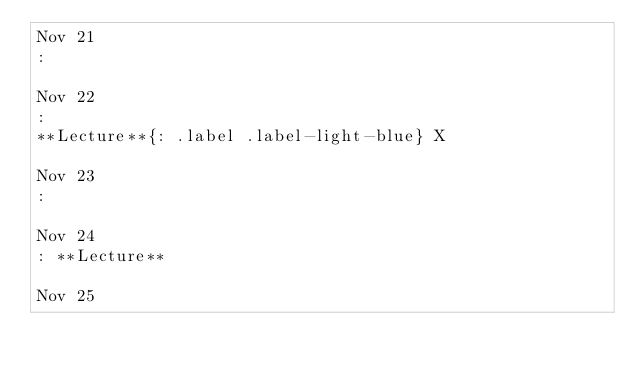<code> <loc_0><loc_0><loc_500><loc_500><_Python_>Nov 21
: 

Nov 22
: 
**Lecture**{: .label .label-light-blue} X

Nov 23
: 

Nov 24
: **Lecture**

Nov 25</code> 